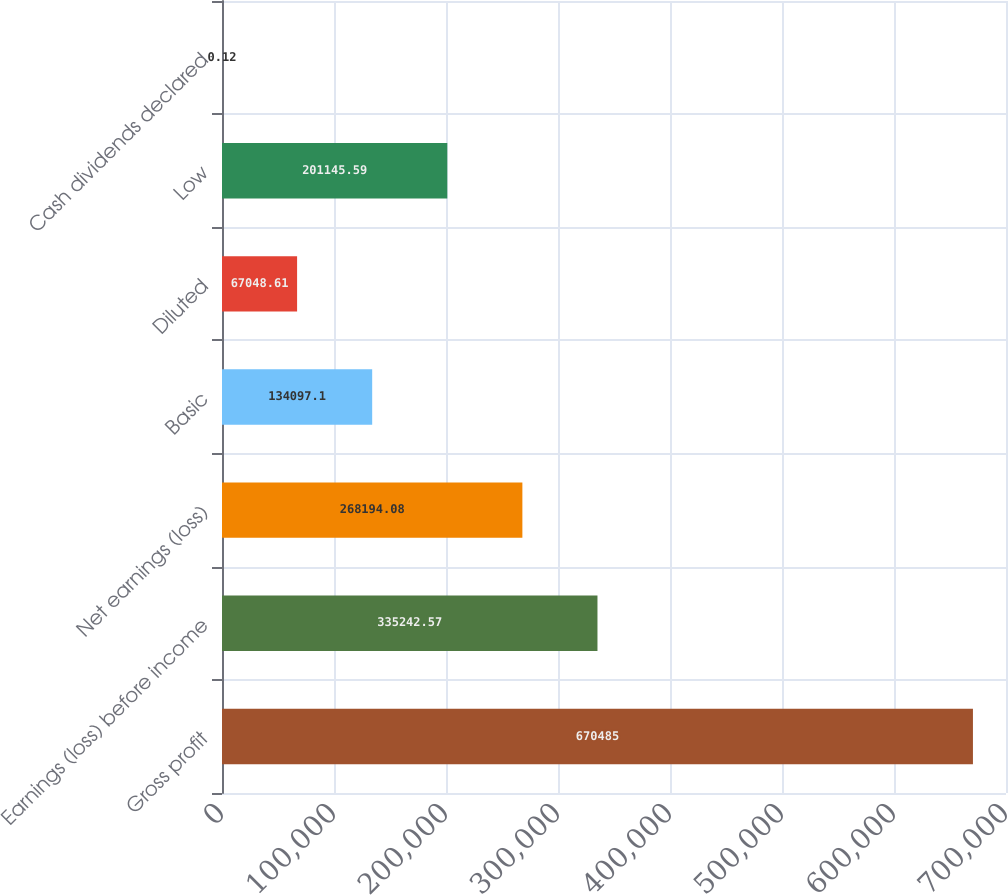<chart> <loc_0><loc_0><loc_500><loc_500><bar_chart><fcel>Gross profit<fcel>Earnings (loss) before income<fcel>Net earnings (loss)<fcel>Basic<fcel>Diluted<fcel>Low<fcel>Cash dividends declared<nl><fcel>670485<fcel>335243<fcel>268194<fcel>134097<fcel>67048.6<fcel>201146<fcel>0.12<nl></chart> 